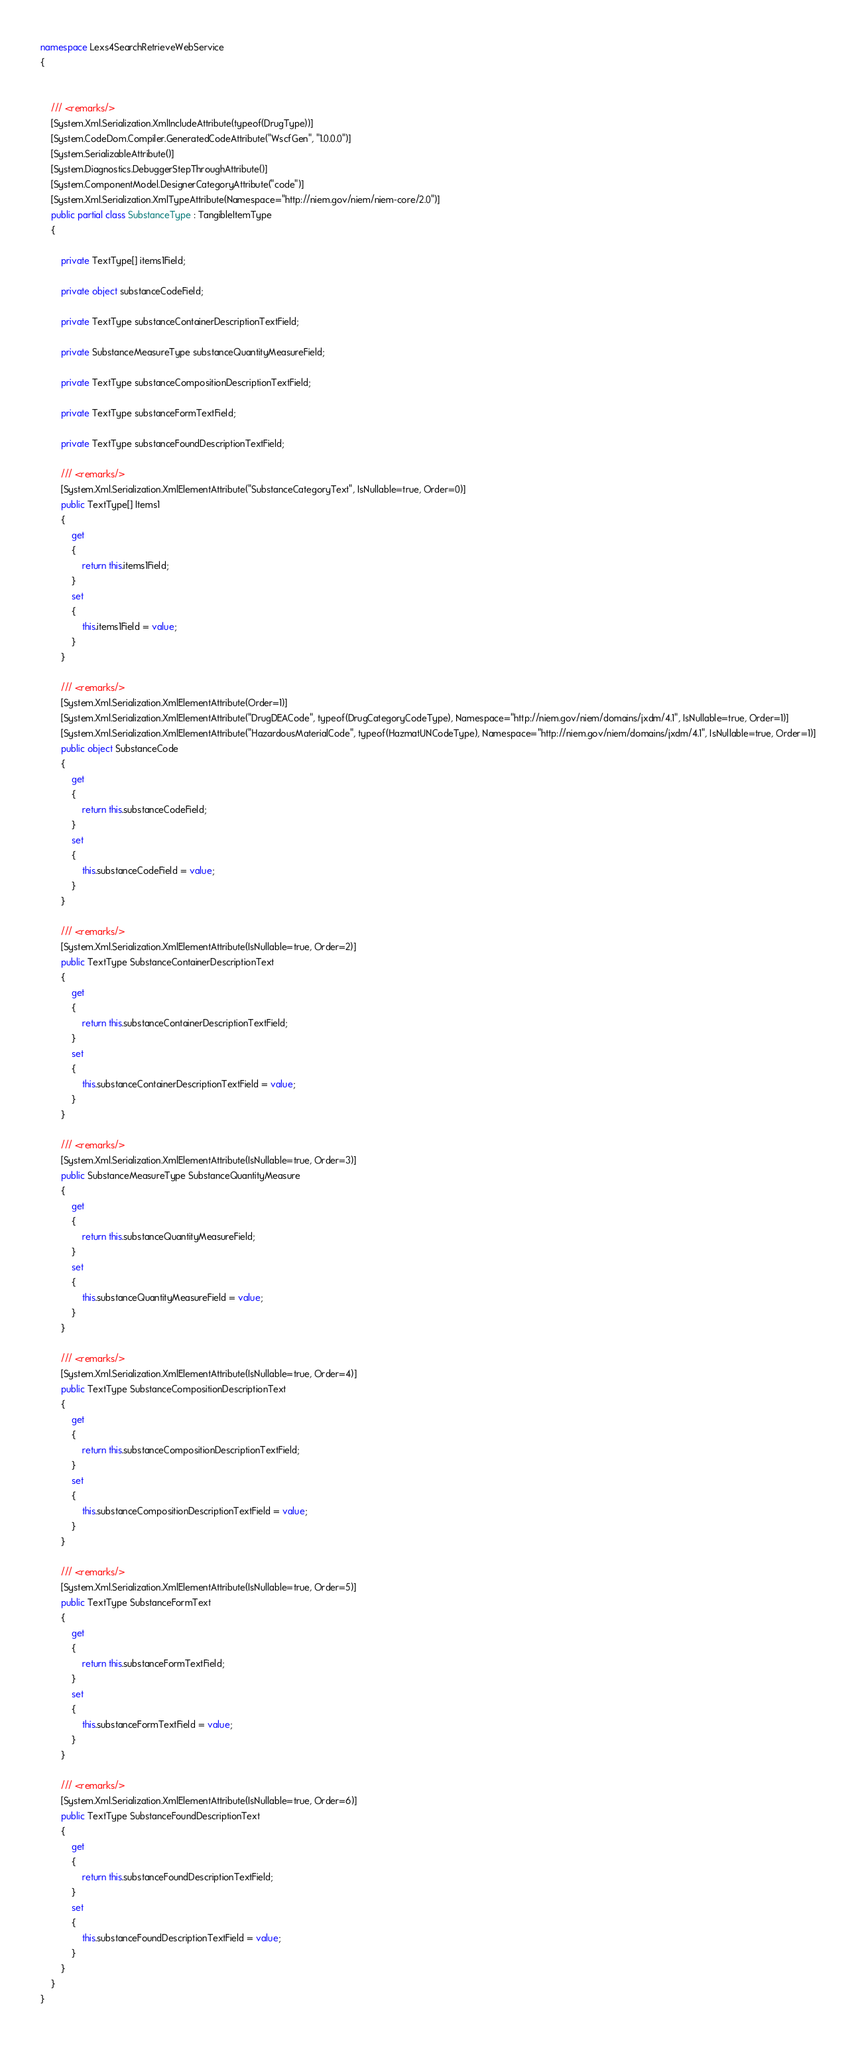<code> <loc_0><loc_0><loc_500><loc_500><_C#_>namespace Lexs4SearchRetrieveWebService
{
    
    
    /// <remarks/>
    [System.Xml.Serialization.XmlIncludeAttribute(typeof(DrugType))]
    [System.CodeDom.Compiler.GeneratedCodeAttribute("WscfGen", "1.0.0.0")]
    [System.SerializableAttribute()]
    [System.Diagnostics.DebuggerStepThroughAttribute()]
    [System.ComponentModel.DesignerCategoryAttribute("code")]
    [System.Xml.Serialization.XmlTypeAttribute(Namespace="http://niem.gov/niem/niem-core/2.0")]
    public partial class SubstanceType : TangibleItemType
    {
        
        private TextType[] items1Field;
        
        private object substanceCodeField;
        
        private TextType substanceContainerDescriptionTextField;
        
        private SubstanceMeasureType substanceQuantityMeasureField;
        
        private TextType substanceCompositionDescriptionTextField;
        
        private TextType substanceFormTextField;
        
        private TextType substanceFoundDescriptionTextField;
        
        /// <remarks/>
        [System.Xml.Serialization.XmlElementAttribute("SubstanceCategoryText", IsNullable=true, Order=0)]
        public TextType[] Items1
        {
            get
            {
                return this.items1Field;
            }
            set
            {
                this.items1Field = value;
            }
        }
        
        /// <remarks/>
        [System.Xml.Serialization.XmlElementAttribute(Order=1)]
        [System.Xml.Serialization.XmlElementAttribute("DrugDEACode", typeof(DrugCategoryCodeType), Namespace="http://niem.gov/niem/domains/jxdm/4.1", IsNullable=true, Order=1)]
        [System.Xml.Serialization.XmlElementAttribute("HazardousMaterialCode", typeof(HazmatUNCodeType), Namespace="http://niem.gov/niem/domains/jxdm/4.1", IsNullable=true, Order=1)]
        public object SubstanceCode
        {
            get
            {
                return this.substanceCodeField;
            }
            set
            {
                this.substanceCodeField = value;
            }
        }
        
        /// <remarks/>
        [System.Xml.Serialization.XmlElementAttribute(IsNullable=true, Order=2)]
        public TextType SubstanceContainerDescriptionText
        {
            get
            {
                return this.substanceContainerDescriptionTextField;
            }
            set
            {
                this.substanceContainerDescriptionTextField = value;
            }
        }
        
        /// <remarks/>
        [System.Xml.Serialization.XmlElementAttribute(IsNullable=true, Order=3)]
        public SubstanceMeasureType SubstanceQuantityMeasure
        {
            get
            {
                return this.substanceQuantityMeasureField;
            }
            set
            {
                this.substanceQuantityMeasureField = value;
            }
        }
        
        /// <remarks/>
        [System.Xml.Serialization.XmlElementAttribute(IsNullable=true, Order=4)]
        public TextType SubstanceCompositionDescriptionText
        {
            get
            {
                return this.substanceCompositionDescriptionTextField;
            }
            set
            {
                this.substanceCompositionDescriptionTextField = value;
            }
        }
        
        /// <remarks/>
        [System.Xml.Serialization.XmlElementAttribute(IsNullable=true, Order=5)]
        public TextType SubstanceFormText
        {
            get
            {
                return this.substanceFormTextField;
            }
            set
            {
                this.substanceFormTextField = value;
            }
        }
        
        /// <remarks/>
        [System.Xml.Serialization.XmlElementAttribute(IsNullable=true, Order=6)]
        public TextType SubstanceFoundDescriptionText
        {
            get
            {
                return this.substanceFoundDescriptionTextField;
            }
            set
            {
                this.substanceFoundDescriptionTextField = value;
            }
        }
    }
}
</code> 